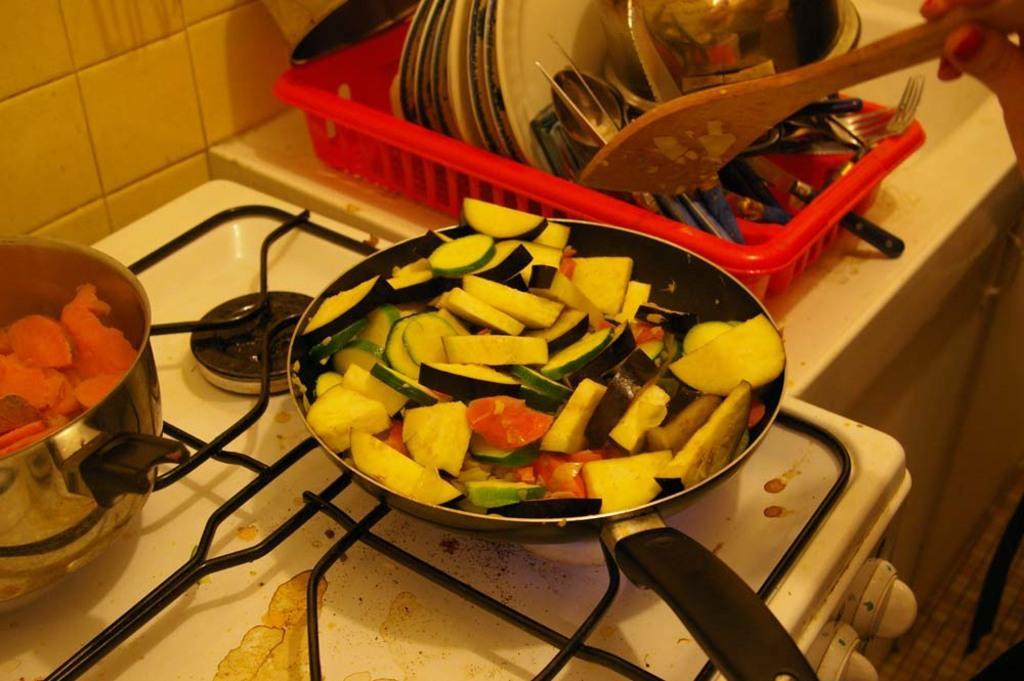Can you describe this image briefly? In this image we can see some food in the pan and a bowl. There is a stove. There are many utensils in the image. We can see a hand of a person. 